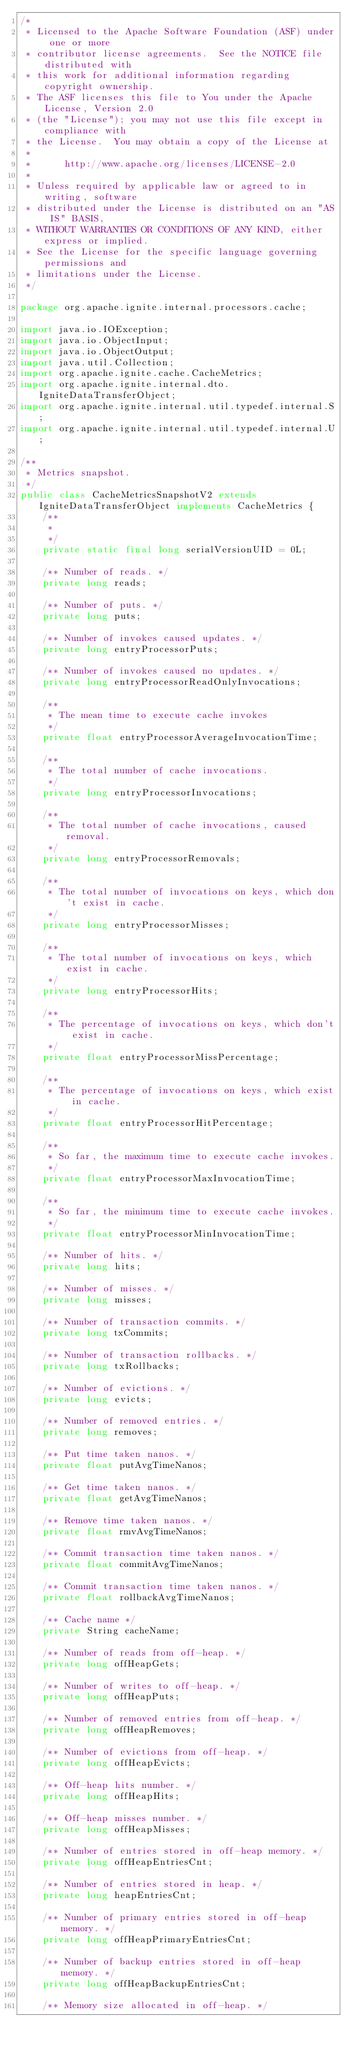Convert code to text. <code><loc_0><loc_0><loc_500><loc_500><_Java_>/*
 * Licensed to the Apache Software Foundation (ASF) under one or more
 * contributor license agreements.  See the NOTICE file distributed with
 * this work for additional information regarding copyright ownership.
 * The ASF licenses this file to You under the Apache License, Version 2.0
 * (the "License"); you may not use this file except in compliance with
 * the License.  You may obtain a copy of the License at
 *
 *      http://www.apache.org/licenses/LICENSE-2.0
 *
 * Unless required by applicable law or agreed to in writing, software
 * distributed under the License is distributed on an "AS IS" BASIS,
 * WITHOUT WARRANTIES OR CONDITIONS OF ANY KIND, either express or implied.
 * See the License for the specific language governing permissions and
 * limitations under the License.
 */

package org.apache.ignite.internal.processors.cache;

import java.io.IOException;
import java.io.ObjectInput;
import java.io.ObjectOutput;
import java.util.Collection;
import org.apache.ignite.cache.CacheMetrics;
import org.apache.ignite.internal.dto.IgniteDataTransferObject;
import org.apache.ignite.internal.util.typedef.internal.S;
import org.apache.ignite.internal.util.typedef.internal.U;

/**
 * Metrics snapshot.
 */
public class CacheMetricsSnapshotV2 extends IgniteDataTransferObject implements CacheMetrics {
    /**
     *
     */
    private static final long serialVersionUID = 0L;

    /** Number of reads. */
    private long reads;

    /** Number of puts. */
    private long puts;

    /** Number of invokes caused updates. */
    private long entryProcessorPuts;

    /** Number of invokes caused no updates. */
    private long entryProcessorReadOnlyInvocations;

    /**
     * The mean time to execute cache invokes
     */
    private float entryProcessorAverageInvocationTime;

    /**
     * The total number of cache invocations.
     */
    private long entryProcessorInvocations;

    /**
     * The total number of cache invocations, caused removal.
     */
    private long entryProcessorRemovals;

    /**
     * The total number of invocations on keys, which don't exist in cache.
     */
    private long entryProcessorMisses;

    /**
     * The total number of invocations on keys, which exist in cache.
     */
    private long entryProcessorHits;

    /**
     * The percentage of invocations on keys, which don't exist in cache.
     */
    private float entryProcessorMissPercentage;

    /**
     * The percentage of invocations on keys, which exist in cache.
     */
    private float entryProcessorHitPercentage;

    /**
     * So far, the maximum time to execute cache invokes.
     */
    private float entryProcessorMaxInvocationTime;

    /**
     * So far, the minimum time to execute cache invokes.
     */
    private float entryProcessorMinInvocationTime;

    /** Number of hits. */
    private long hits;

    /** Number of misses. */
    private long misses;

    /** Number of transaction commits. */
    private long txCommits;

    /** Number of transaction rollbacks. */
    private long txRollbacks;

    /** Number of evictions. */
    private long evicts;

    /** Number of removed entries. */
    private long removes;

    /** Put time taken nanos. */
    private float putAvgTimeNanos;

    /** Get time taken nanos. */
    private float getAvgTimeNanos;

    /** Remove time taken nanos. */
    private float rmvAvgTimeNanos;

    /** Commit transaction time taken nanos. */
    private float commitAvgTimeNanos;

    /** Commit transaction time taken nanos. */
    private float rollbackAvgTimeNanos;

    /** Cache name */
    private String cacheName;

    /** Number of reads from off-heap. */
    private long offHeapGets;

    /** Number of writes to off-heap. */
    private long offHeapPuts;

    /** Number of removed entries from off-heap. */
    private long offHeapRemoves;

    /** Number of evictions from off-heap. */
    private long offHeapEvicts;

    /** Off-heap hits number. */
    private long offHeapHits;

    /** Off-heap misses number. */
    private long offHeapMisses;

    /** Number of entries stored in off-heap memory. */
    private long offHeapEntriesCnt;

    /** Number of entries stored in heap. */
    private long heapEntriesCnt;

    /** Number of primary entries stored in off-heap memory. */
    private long offHeapPrimaryEntriesCnt;

    /** Number of backup entries stored in off-heap memory. */
    private long offHeapBackupEntriesCnt;

    /** Memory size allocated in off-heap. */</code> 